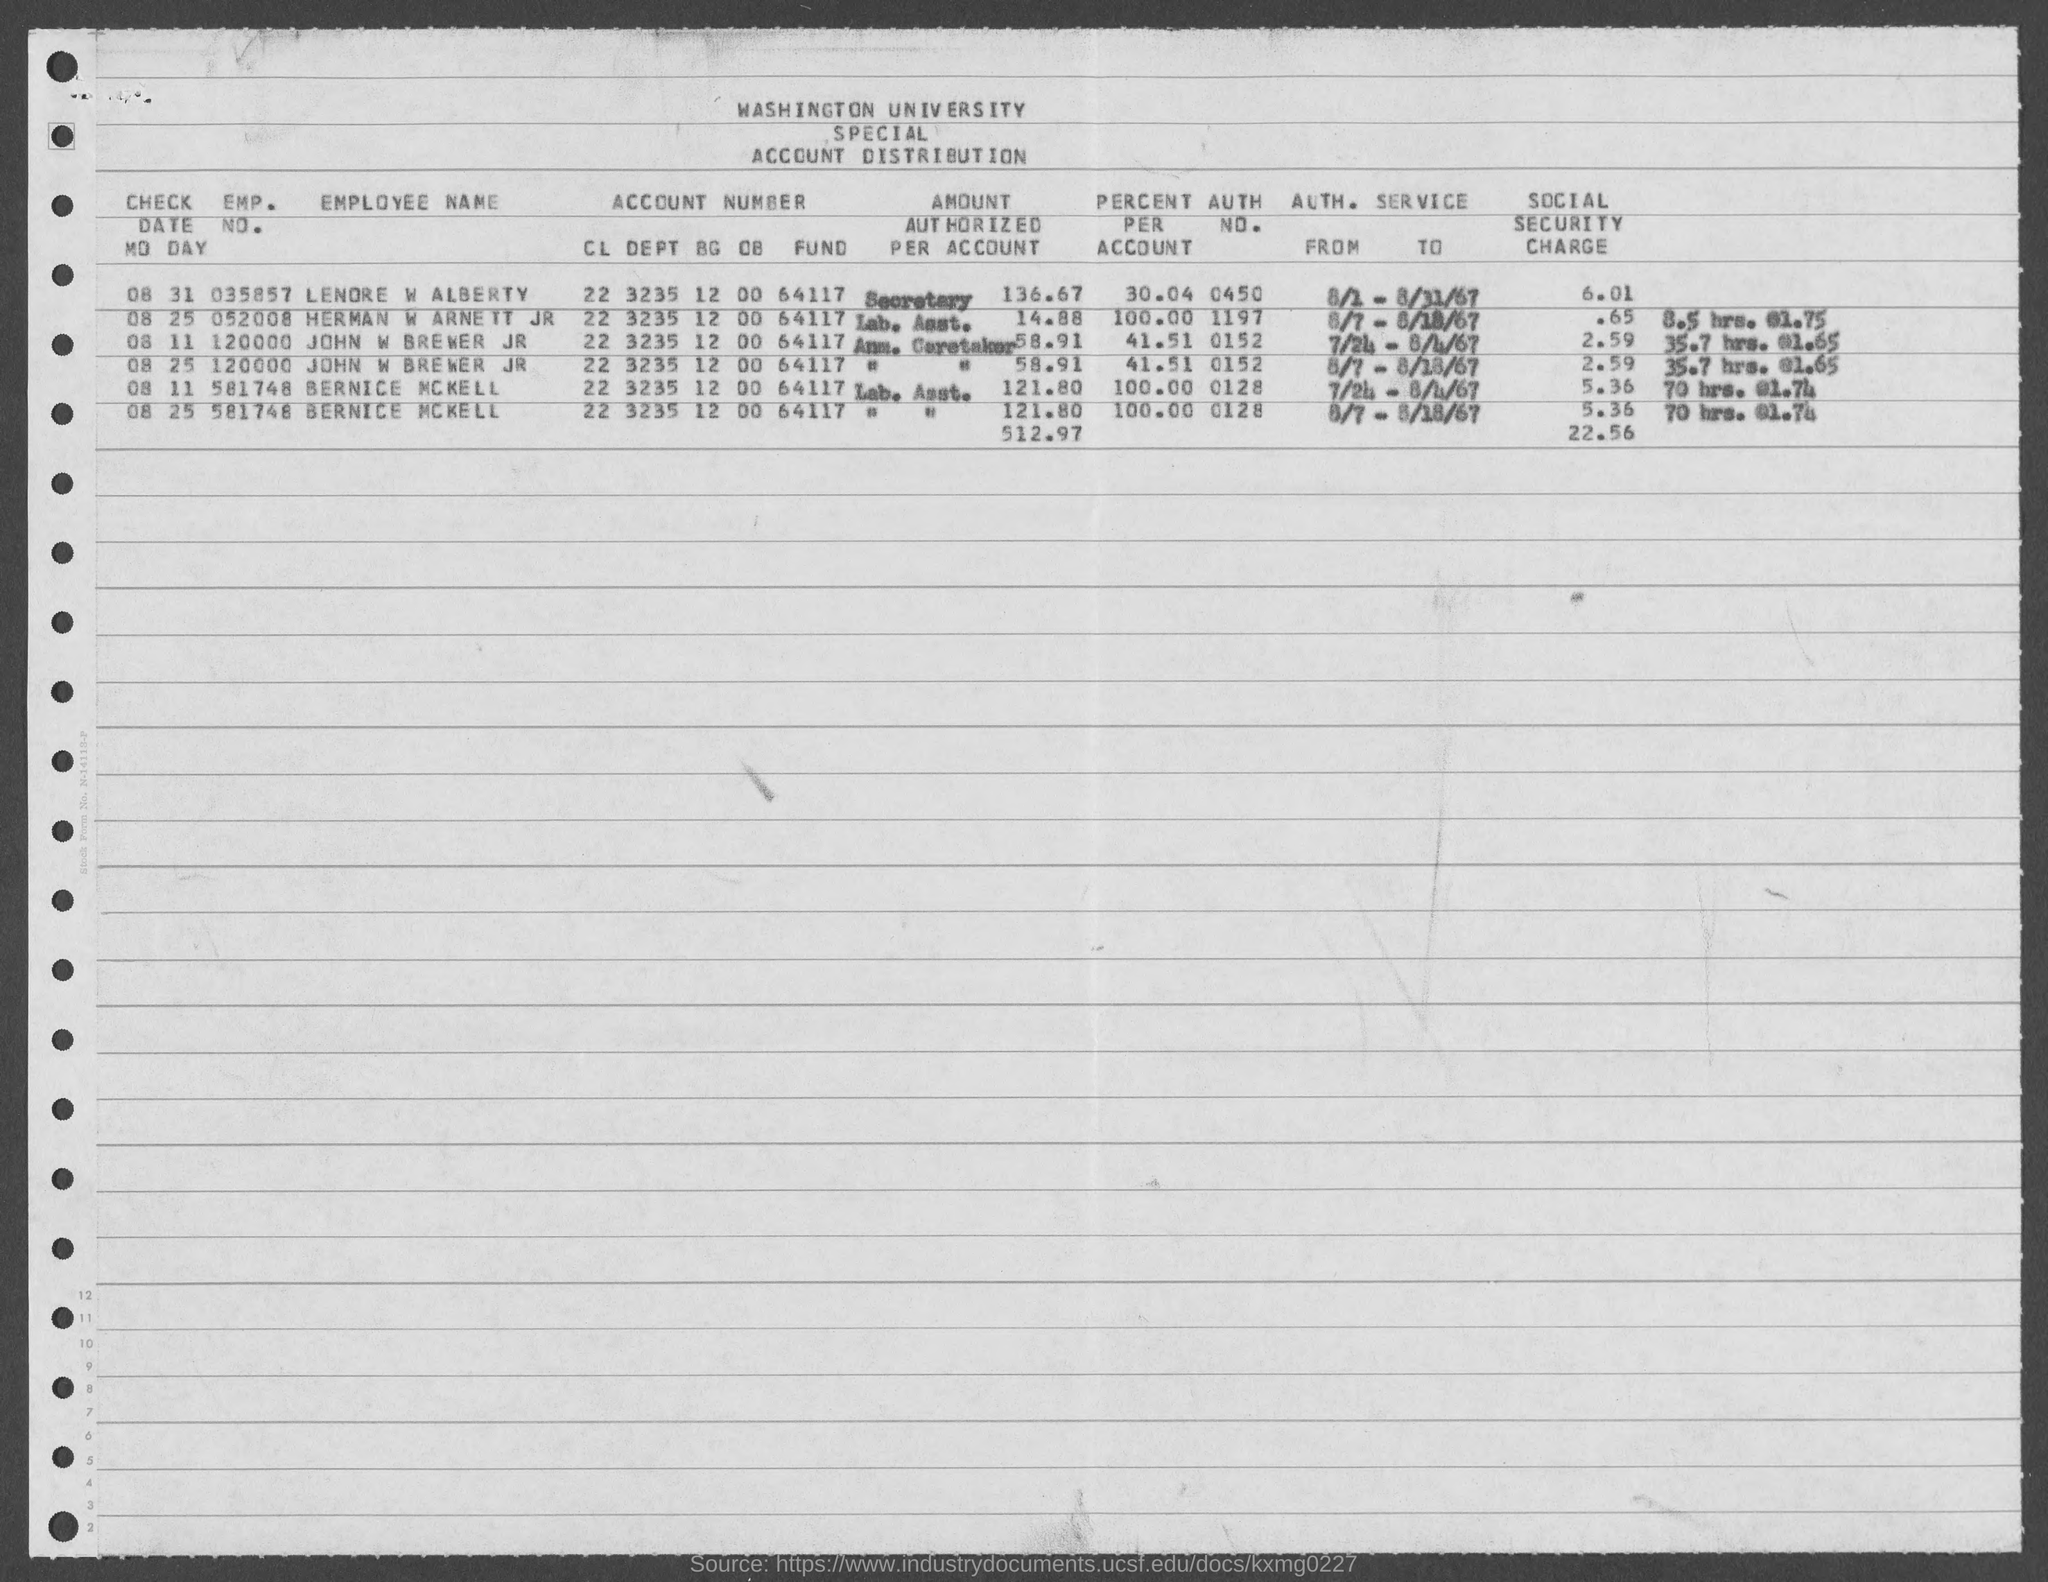Give some essential details in this illustration. The authorization number for John W. Brewer Jr. is 0152. The emp. no. of Bernice McKell as mentioned in the given form is 581748. The emp. no. of John W. Brewer Jr. as mentioned on the given page is 120000. The Emp. No. for Lenore W. Alaberty mentioned in the given page is 035857. 